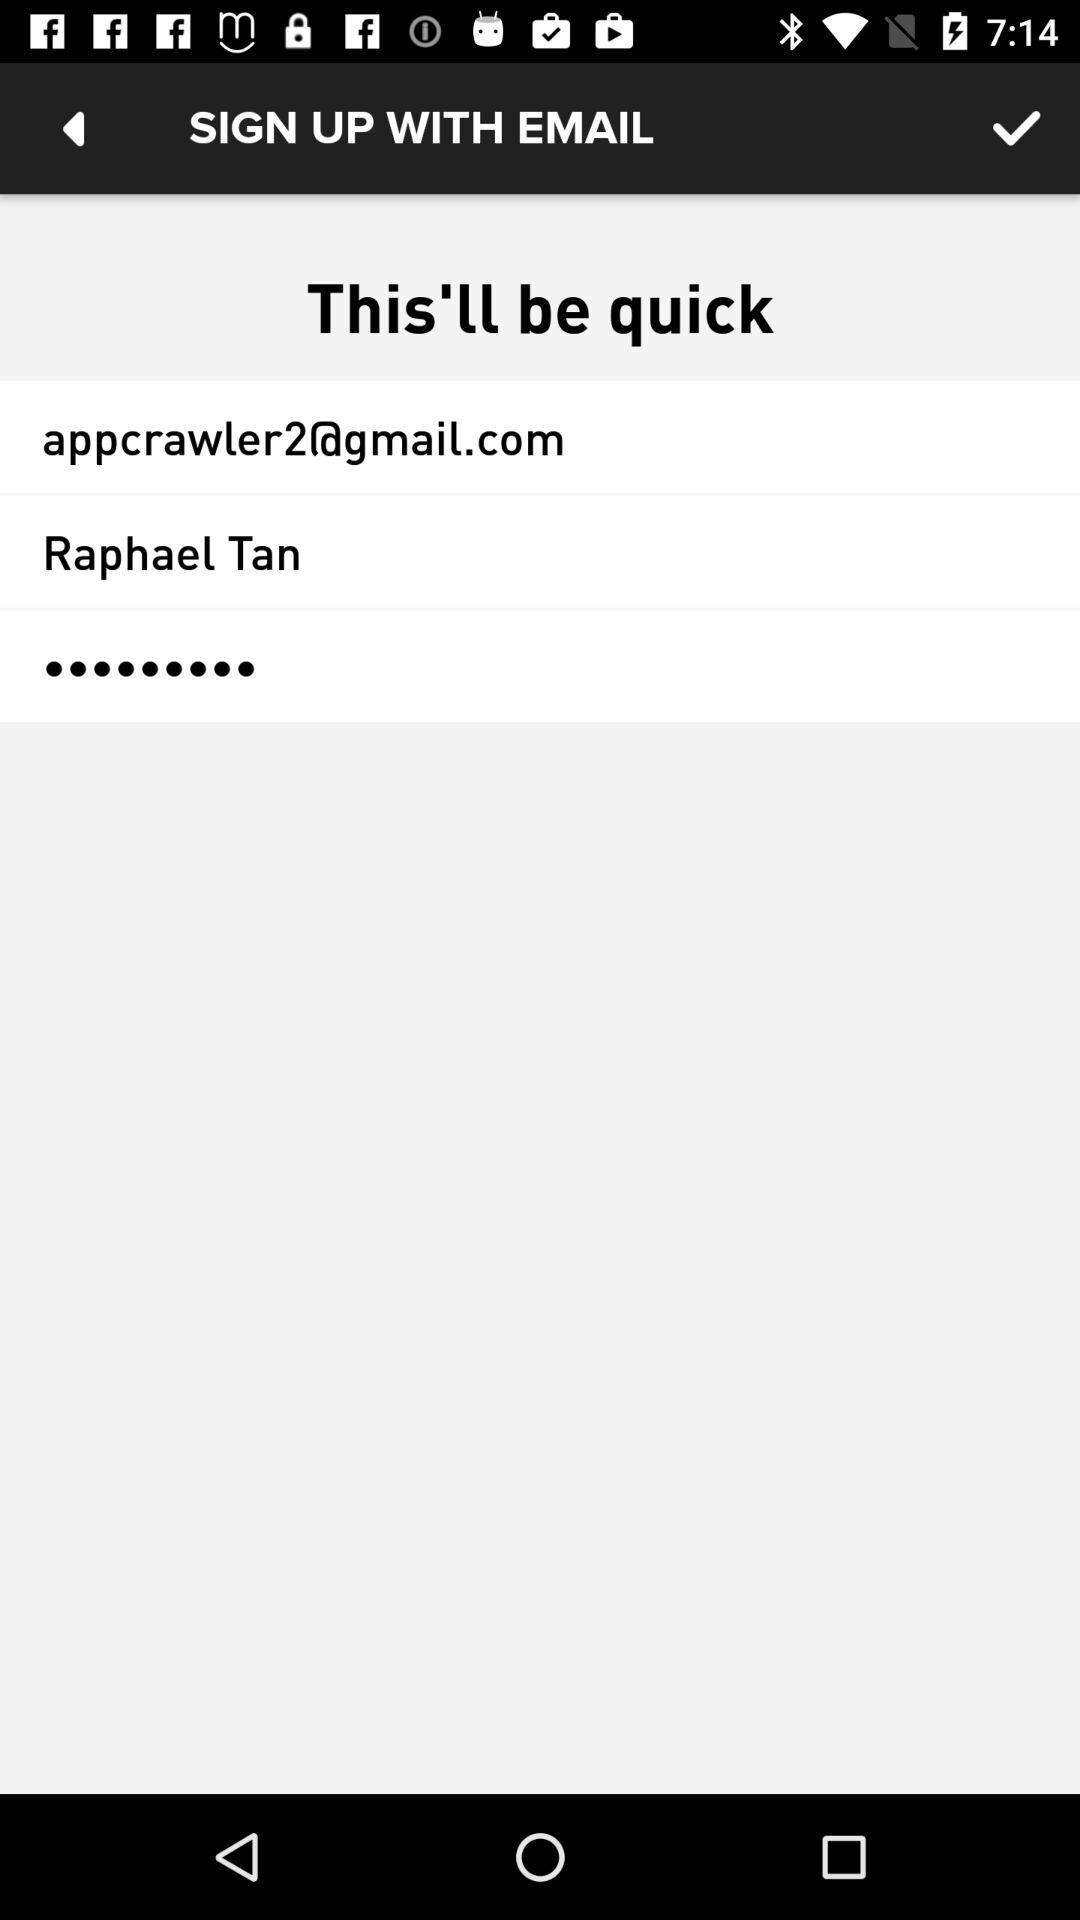What is the username? The username is Raphael Tan. 